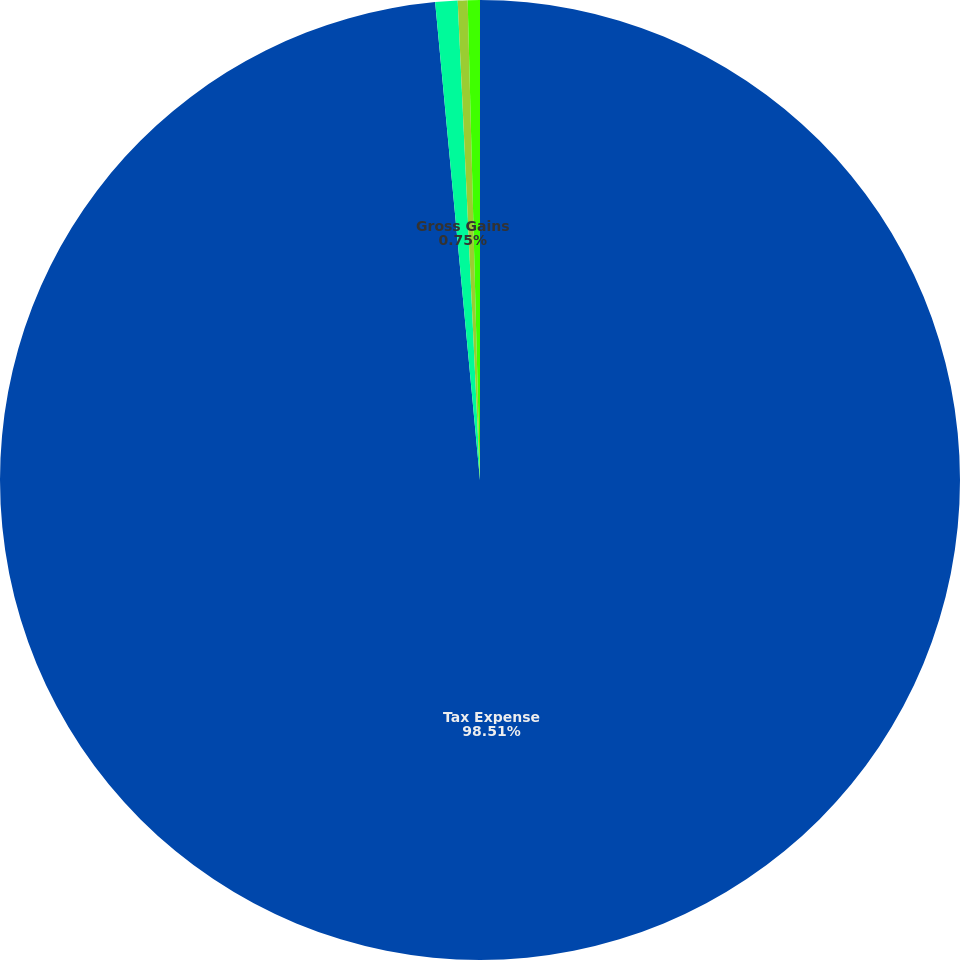<chart> <loc_0><loc_0><loc_500><loc_500><pie_chart><fcel>Tax Expense<fcel>Gross Gains<fcel>Proceeds<fcel>Net Gains<nl><fcel>98.51%<fcel>0.75%<fcel>0.33%<fcel>0.41%<nl></chart> 